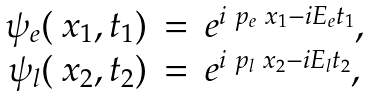Convert formula to latex. <formula><loc_0><loc_0><loc_500><loc_500>\begin{array} { r c l } \psi _ { e } ( \ x _ { 1 } , t _ { 1 } ) & = & e ^ { i \ p _ { e } \ x _ { 1 } - i E _ { e } t _ { 1 } } , \\ \psi _ { l } ( \ x _ { 2 } , t _ { 2 } ) & = & e ^ { i \ p _ { l } \ x _ { 2 } - i E _ { l } t _ { 2 } } , \\ \end{array}</formula> 